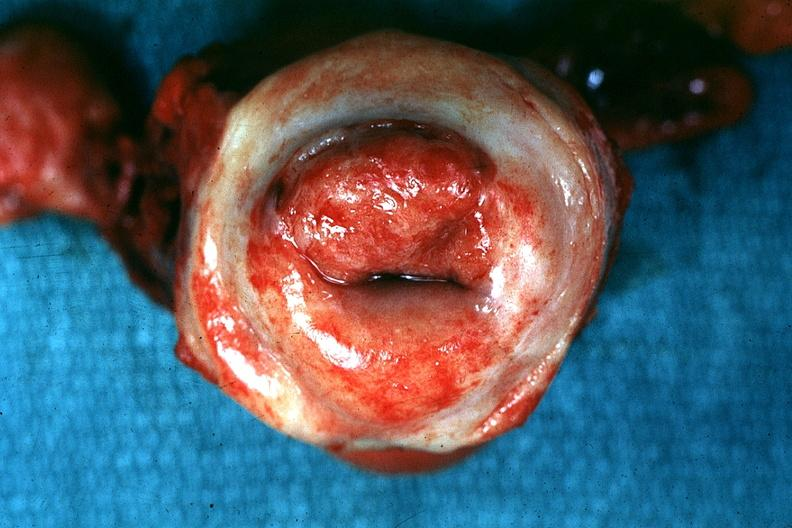what is present?
Answer the question using a single word or phrase. Uterus 